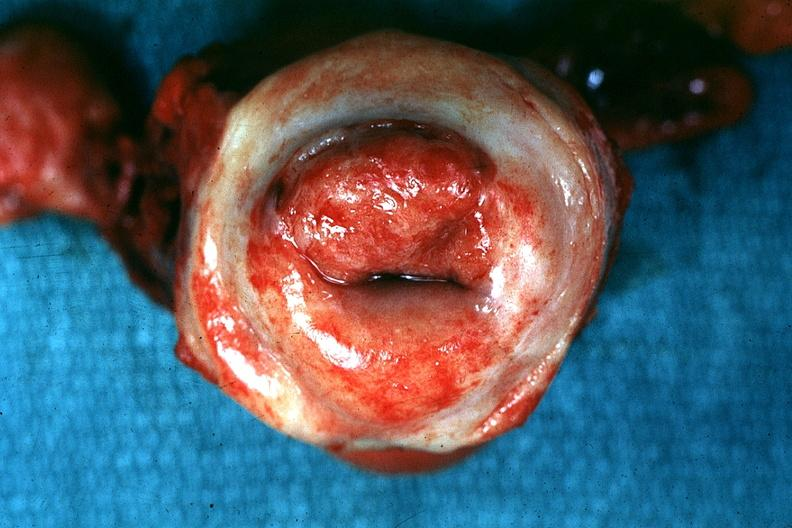what is present?
Answer the question using a single word or phrase. Uterus 